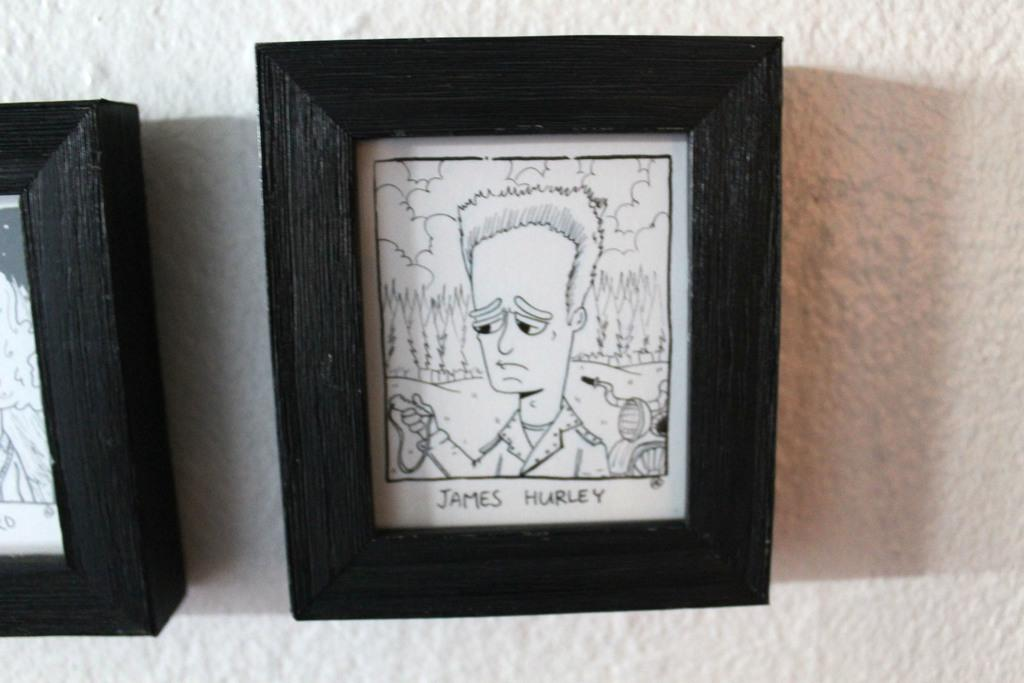What is hanging on the wall in the image? There are frames on the wall in the image. What is inside the frames? The frames contain text and images. What type of joke is depicted in the frames on the wall? There is no joke present in the image; the frames contain text and images. 